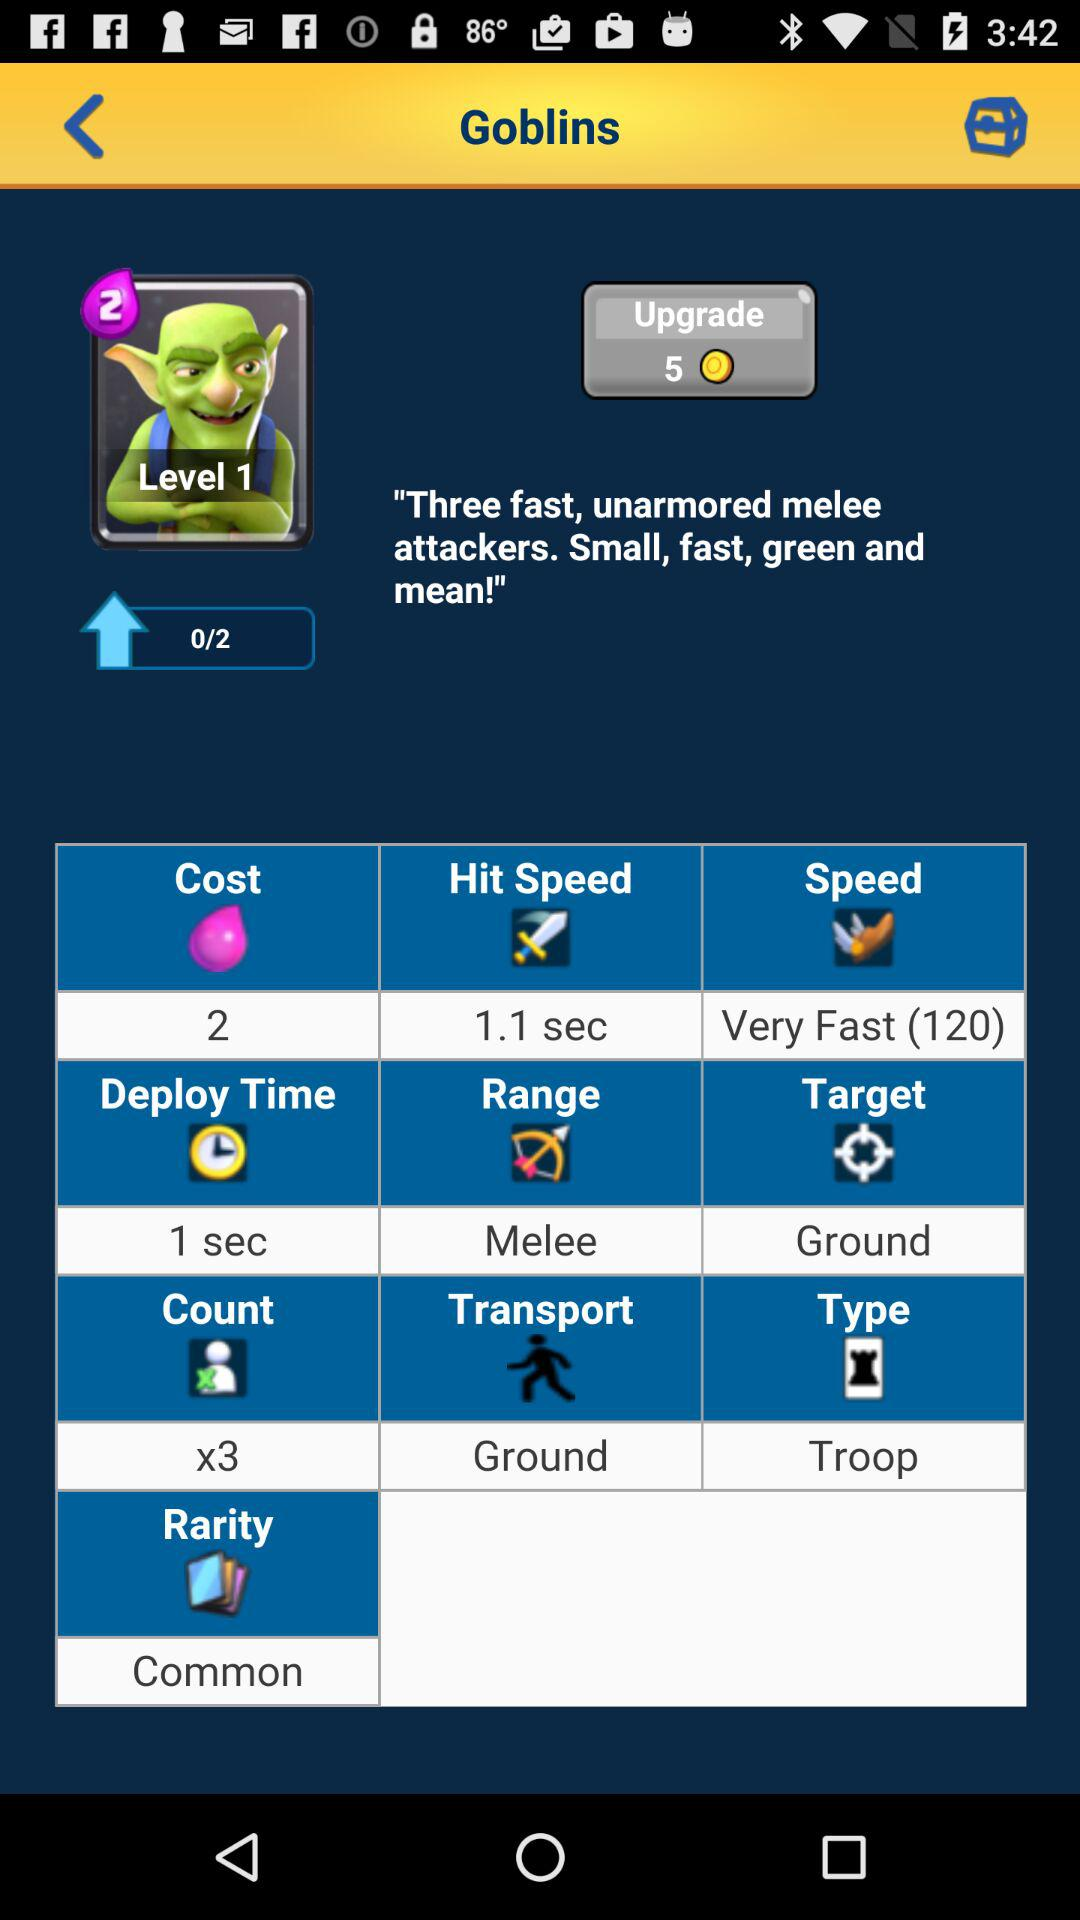How many coins are required to upgrade? The number of coins required to upgrade is 5. 